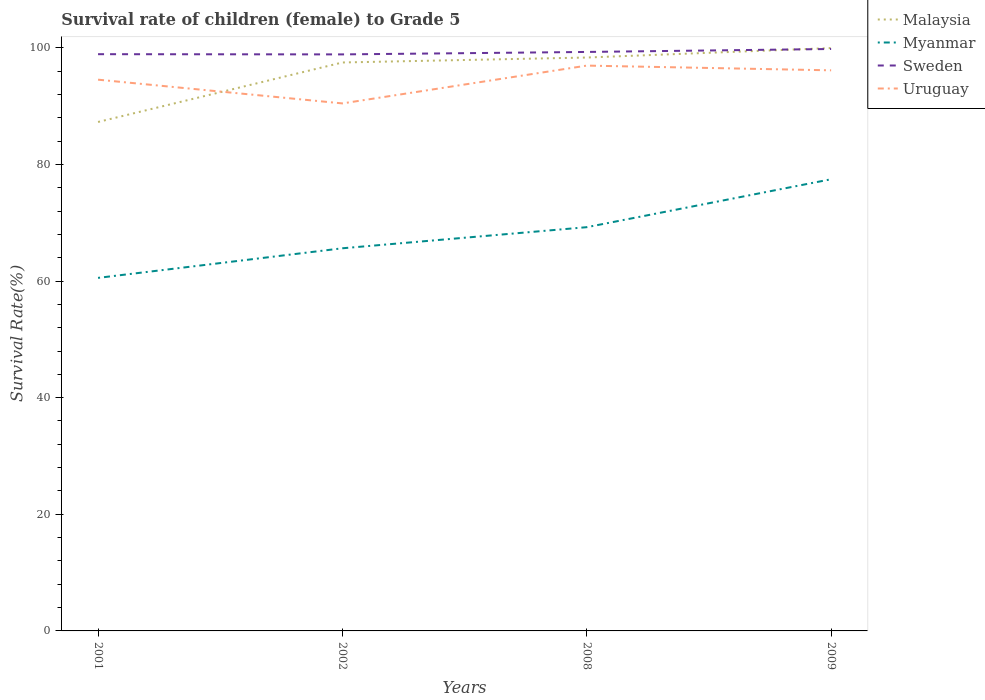Does the line corresponding to Uruguay intersect with the line corresponding to Sweden?
Give a very brief answer. No. Is the number of lines equal to the number of legend labels?
Keep it short and to the point. Yes. Across all years, what is the maximum survival rate of female children to grade 5 in Myanmar?
Your answer should be compact. 60.54. What is the total survival rate of female children to grade 5 in Myanmar in the graph?
Keep it short and to the point. -16.91. What is the difference between the highest and the second highest survival rate of female children to grade 5 in Uruguay?
Offer a terse response. 6.48. Is the survival rate of female children to grade 5 in Uruguay strictly greater than the survival rate of female children to grade 5 in Myanmar over the years?
Offer a terse response. No. How many years are there in the graph?
Your answer should be very brief. 4. What is the difference between two consecutive major ticks on the Y-axis?
Provide a succinct answer. 20. Does the graph contain any zero values?
Ensure brevity in your answer.  No. Where does the legend appear in the graph?
Ensure brevity in your answer.  Top right. What is the title of the graph?
Give a very brief answer. Survival rate of children (female) to Grade 5. Does "Greenland" appear as one of the legend labels in the graph?
Ensure brevity in your answer.  No. What is the label or title of the Y-axis?
Your answer should be very brief. Survival Rate(%). What is the Survival Rate(%) of Malaysia in 2001?
Ensure brevity in your answer.  87.27. What is the Survival Rate(%) in Myanmar in 2001?
Provide a succinct answer. 60.54. What is the Survival Rate(%) of Sweden in 2001?
Provide a succinct answer. 98.9. What is the Survival Rate(%) of Uruguay in 2001?
Provide a short and direct response. 94.53. What is the Survival Rate(%) of Malaysia in 2002?
Offer a terse response. 97.48. What is the Survival Rate(%) in Myanmar in 2002?
Ensure brevity in your answer.  65.61. What is the Survival Rate(%) in Sweden in 2002?
Provide a succinct answer. 98.86. What is the Survival Rate(%) in Uruguay in 2002?
Provide a short and direct response. 90.46. What is the Survival Rate(%) of Malaysia in 2008?
Your response must be concise. 98.32. What is the Survival Rate(%) of Myanmar in 2008?
Your answer should be very brief. 69.23. What is the Survival Rate(%) in Sweden in 2008?
Your answer should be very brief. 99.28. What is the Survival Rate(%) in Uruguay in 2008?
Keep it short and to the point. 96.94. What is the Survival Rate(%) of Malaysia in 2009?
Offer a terse response. 99.95. What is the Survival Rate(%) in Myanmar in 2009?
Ensure brevity in your answer.  77.45. What is the Survival Rate(%) of Sweden in 2009?
Keep it short and to the point. 99.79. What is the Survival Rate(%) in Uruguay in 2009?
Your answer should be very brief. 96.13. Across all years, what is the maximum Survival Rate(%) of Malaysia?
Ensure brevity in your answer.  99.95. Across all years, what is the maximum Survival Rate(%) in Myanmar?
Make the answer very short. 77.45. Across all years, what is the maximum Survival Rate(%) of Sweden?
Your answer should be very brief. 99.79. Across all years, what is the maximum Survival Rate(%) of Uruguay?
Offer a terse response. 96.94. Across all years, what is the minimum Survival Rate(%) of Malaysia?
Provide a short and direct response. 87.27. Across all years, what is the minimum Survival Rate(%) in Myanmar?
Your response must be concise. 60.54. Across all years, what is the minimum Survival Rate(%) of Sweden?
Give a very brief answer. 98.86. Across all years, what is the minimum Survival Rate(%) in Uruguay?
Your answer should be compact. 90.46. What is the total Survival Rate(%) in Malaysia in the graph?
Keep it short and to the point. 383.02. What is the total Survival Rate(%) in Myanmar in the graph?
Provide a short and direct response. 272.84. What is the total Survival Rate(%) of Sweden in the graph?
Ensure brevity in your answer.  396.83. What is the total Survival Rate(%) of Uruguay in the graph?
Ensure brevity in your answer.  378.05. What is the difference between the Survival Rate(%) of Malaysia in 2001 and that in 2002?
Your answer should be very brief. -10.2. What is the difference between the Survival Rate(%) in Myanmar in 2001 and that in 2002?
Give a very brief answer. -5.08. What is the difference between the Survival Rate(%) of Sweden in 2001 and that in 2002?
Your response must be concise. 0.04. What is the difference between the Survival Rate(%) in Uruguay in 2001 and that in 2002?
Your response must be concise. 4.07. What is the difference between the Survival Rate(%) in Malaysia in 2001 and that in 2008?
Offer a very short reply. -11.05. What is the difference between the Survival Rate(%) of Myanmar in 2001 and that in 2008?
Ensure brevity in your answer.  -8.69. What is the difference between the Survival Rate(%) in Sweden in 2001 and that in 2008?
Offer a terse response. -0.38. What is the difference between the Survival Rate(%) in Uruguay in 2001 and that in 2008?
Provide a short and direct response. -2.41. What is the difference between the Survival Rate(%) of Malaysia in 2001 and that in 2009?
Give a very brief answer. -12.67. What is the difference between the Survival Rate(%) in Myanmar in 2001 and that in 2009?
Ensure brevity in your answer.  -16.91. What is the difference between the Survival Rate(%) of Sweden in 2001 and that in 2009?
Your answer should be compact. -0.89. What is the difference between the Survival Rate(%) of Uruguay in 2001 and that in 2009?
Ensure brevity in your answer.  -1.6. What is the difference between the Survival Rate(%) of Malaysia in 2002 and that in 2008?
Ensure brevity in your answer.  -0.85. What is the difference between the Survival Rate(%) of Myanmar in 2002 and that in 2008?
Your answer should be compact. -3.62. What is the difference between the Survival Rate(%) of Sweden in 2002 and that in 2008?
Make the answer very short. -0.42. What is the difference between the Survival Rate(%) in Uruguay in 2002 and that in 2008?
Make the answer very short. -6.48. What is the difference between the Survival Rate(%) of Malaysia in 2002 and that in 2009?
Keep it short and to the point. -2.47. What is the difference between the Survival Rate(%) in Myanmar in 2002 and that in 2009?
Ensure brevity in your answer.  -11.84. What is the difference between the Survival Rate(%) of Sweden in 2002 and that in 2009?
Make the answer very short. -0.93. What is the difference between the Survival Rate(%) in Uruguay in 2002 and that in 2009?
Offer a very short reply. -5.67. What is the difference between the Survival Rate(%) of Malaysia in 2008 and that in 2009?
Offer a very short reply. -1.62. What is the difference between the Survival Rate(%) in Myanmar in 2008 and that in 2009?
Provide a short and direct response. -8.22. What is the difference between the Survival Rate(%) of Sweden in 2008 and that in 2009?
Provide a succinct answer. -0.51. What is the difference between the Survival Rate(%) of Uruguay in 2008 and that in 2009?
Provide a short and direct response. 0.81. What is the difference between the Survival Rate(%) in Malaysia in 2001 and the Survival Rate(%) in Myanmar in 2002?
Offer a terse response. 21.66. What is the difference between the Survival Rate(%) of Malaysia in 2001 and the Survival Rate(%) of Sweden in 2002?
Provide a short and direct response. -11.59. What is the difference between the Survival Rate(%) in Malaysia in 2001 and the Survival Rate(%) in Uruguay in 2002?
Your response must be concise. -3.18. What is the difference between the Survival Rate(%) of Myanmar in 2001 and the Survival Rate(%) of Sweden in 2002?
Your response must be concise. -38.32. What is the difference between the Survival Rate(%) in Myanmar in 2001 and the Survival Rate(%) in Uruguay in 2002?
Offer a very short reply. -29.92. What is the difference between the Survival Rate(%) of Sweden in 2001 and the Survival Rate(%) of Uruguay in 2002?
Keep it short and to the point. 8.44. What is the difference between the Survival Rate(%) of Malaysia in 2001 and the Survival Rate(%) of Myanmar in 2008?
Offer a very short reply. 18.04. What is the difference between the Survival Rate(%) of Malaysia in 2001 and the Survival Rate(%) of Sweden in 2008?
Keep it short and to the point. -12.01. What is the difference between the Survival Rate(%) in Malaysia in 2001 and the Survival Rate(%) in Uruguay in 2008?
Your response must be concise. -9.67. What is the difference between the Survival Rate(%) in Myanmar in 2001 and the Survival Rate(%) in Sweden in 2008?
Ensure brevity in your answer.  -38.74. What is the difference between the Survival Rate(%) in Myanmar in 2001 and the Survival Rate(%) in Uruguay in 2008?
Your response must be concise. -36.4. What is the difference between the Survival Rate(%) of Sweden in 2001 and the Survival Rate(%) of Uruguay in 2008?
Offer a terse response. 1.96. What is the difference between the Survival Rate(%) of Malaysia in 2001 and the Survival Rate(%) of Myanmar in 2009?
Make the answer very short. 9.82. What is the difference between the Survival Rate(%) in Malaysia in 2001 and the Survival Rate(%) in Sweden in 2009?
Keep it short and to the point. -12.52. What is the difference between the Survival Rate(%) in Malaysia in 2001 and the Survival Rate(%) in Uruguay in 2009?
Your response must be concise. -8.86. What is the difference between the Survival Rate(%) of Myanmar in 2001 and the Survival Rate(%) of Sweden in 2009?
Offer a very short reply. -39.25. What is the difference between the Survival Rate(%) in Myanmar in 2001 and the Survival Rate(%) in Uruguay in 2009?
Your answer should be compact. -35.59. What is the difference between the Survival Rate(%) of Sweden in 2001 and the Survival Rate(%) of Uruguay in 2009?
Keep it short and to the point. 2.77. What is the difference between the Survival Rate(%) in Malaysia in 2002 and the Survival Rate(%) in Myanmar in 2008?
Offer a terse response. 28.24. What is the difference between the Survival Rate(%) of Malaysia in 2002 and the Survival Rate(%) of Sweden in 2008?
Your answer should be compact. -1.8. What is the difference between the Survival Rate(%) of Malaysia in 2002 and the Survival Rate(%) of Uruguay in 2008?
Your answer should be compact. 0.54. What is the difference between the Survival Rate(%) in Myanmar in 2002 and the Survival Rate(%) in Sweden in 2008?
Your answer should be very brief. -33.67. What is the difference between the Survival Rate(%) in Myanmar in 2002 and the Survival Rate(%) in Uruguay in 2008?
Provide a succinct answer. -31.33. What is the difference between the Survival Rate(%) of Sweden in 2002 and the Survival Rate(%) of Uruguay in 2008?
Your response must be concise. 1.92. What is the difference between the Survival Rate(%) in Malaysia in 2002 and the Survival Rate(%) in Myanmar in 2009?
Ensure brevity in your answer.  20.02. What is the difference between the Survival Rate(%) of Malaysia in 2002 and the Survival Rate(%) of Sweden in 2009?
Make the answer very short. -2.31. What is the difference between the Survival Rate(%) of Malaysia in 2002 and the Survival Rate(%) of Uruguay in 2009?
Your answer should be very brief. 1.35. What is the difference between the Survival Rate(%) in Myanmar in 2002 and the Survival Rate(%) in Sweden in 2009?
Make the answer very short. -34.17. What is the difference between the Survival Rate(%) in Myanmar in 2002 and the Survival Rate(%) in Uruguay in 2009?
Your response must be concise. -30.51. What is the difference between the Survival Rate(%) in Sweden in 2002 and the Survival Rate(%) in Uruguay in 2009?
Ensure brevity in your answer.  2.73. What is the difference between the Survival Rate(%) in Malaysia in 2008 and the Survival Rate(%) in Myanmar in 2009?
Offer a very short reply. 20.87. What is the difference between the Survival Rate(%) of Malaysia in 2008 and the Survival Rate(%) of Sweden in 2009?
Give a very brief answer. -1.46. What is the difference between the Survival Rate(%) in Malaysia in 2008 and the Survival Rate(%) in Uruguay in 2009?
Provide a short and direct response. 2.2. What is the difference between the Survival Rate(%) in Myanmar in 2008 and the Survival Rate(%) in Sweden in 2009?
Provide a succinct answer. -30.56. What is the difference between the Survival Rate(%) in Myanmar in 2008 and the Survival Rate(%) in Uruguay in 2009?
Your response must be concise. -26.9. What is the difference between the Survival Rate(%) in Sweden in 2008 and the Survival Rate(%) in Uruguay in 2009?
Offer a terse response. 3.15. What is the average Survival Rate(%) in Malaysia per year?
Keep it short and to the point. 95.75. What is the average Survival Rate(%) in Myanmar per year?
Make the answer very short. 68.21. What is the average Survival Rate(%) in Sweden per year?
Provide a short and direct response. 99.21. What is the average Survival Rate(%) in Uruguay per year?
Offer a terse response. 94.51. In the year 2001, what is the difference between the Survival Rate(%) in Malaysia and Survival Rate(%) in Myanmar?
Your response must be concise. 26.73. In the year 2001, what is the difference between the Survival Rate(%) of Malaysia and Survival Rate(%) of Sweden?
Provide a short and direct response. -11.63. In the year 2001, what is the difference between the Survival Rate(%) of Malaysia and Survival Rate(%) of Uruguay?
Offer a very short reply. -7.25. In the year 2001, what is the difference between the Survival Rate(%) in Myanmar and Survival Rate(%) in Sweden?
Ensure brevity in your answer.  -38.36. In the year 2001, what is the difference between the Survival Rate(%) in Myanmar and Survival Rate(%) in Uruguay?
Offer a terse response. -33.99. In the year 2001, what is the difference between the Survival Rate(%) in Sweden and Survival Rate(%) in Uruguay?
Your answer should be very brief. 4.37. In the year 2002, what is the difference between the Survival Rate(%) of Malaysia and Survival Rate(%) of Myanmar?
Your answer should be very brief. 31.86. In the year 2002, what is the difference between the Survival Rate(%) of Malaysia and Survival Rate(%) of Sweden?
Your answer should be compact. -1.39. In the year 2002, what is the difference between the Survival Rate(%) in Malaysia and Survival Rate(%) in Uruguay?
Your answer should be compact. 7.02. In the year 2002, what is the difference between the Survival Rate(%) in Myanmar and Survival Rate(%) in Sweden?
Provide a short and direct response. -33.25. In the year 2002, what is the difference between the Survival Rate(%) of Myanmar and Survival Rate(%) of Uruguay?
Provide a succinct answer. -24.84. In the year 2002, what is the difference between the Survival Rate(%) in Sweden and Survival Rate(%) in Uruguay?
Provide a succinct answer. 8.41. In the year 2008, what is the difference between the Survival Rate(%) in Malaysia and Survival Rate(%) in Myanmar?
Make the answer very short. 29.09. In the year 2008, what is the difference between the Survival Rate(%) of Malaysia and Survival Rate(%) of Sweden?
Offer a very short reply. -0.96. In the year 2008, what is the difference between the Survival Rate(%) of Malaysia and Survival Rate(%) of Uruguay?
Offer a terse response. 1.38. In the year 2008, what is the difference between the Survival Rate(%) in Myanmar and Survival Rate(%) in Sweden?
Offer a terse response. -30.05. In the year 2008, what is the difference between the Survival Rate(%) of Myanmar and Survival Rate(%) of Uruguay?
Make the answer very short. -27.71. In the year 2008, what is the difference between the Survival Rate(%) in Sweden and Survival Rate(%) in Uruguay?
Provide a succinct answer. 2.34. In the year 2009, what is the difference between the Survival Rate(%) in Malaysia and Survival Rate(%) in Myanmar?
Give a very brief answer. 22.5. In the year 2009, what is the difference between the Survival Rate(%) of Malaysia and Survival Rate(%) of Sweden?
Offer a very short reply. 0.16. In the year 2009, what is the difference between the Survival Rate(%) in Malaysia and Survival Rate(%) in Uruguay?
Provide a short and direct response. 3.82. In the year 2009, what is the difference between the Survival Rate(%) in Myanmar and Survival Rate(%) in Sweden?
Provide a short and direct response. -22.34. In the year 2009, what is the difference between the Survival Rate(%) in Myanmar and Survival Rate(%) in Uruguay?
Offer a very short reply. -18.68. In the year 2009, what is the difference between the Survival Rate(%) of Sweden and Survival Rate(%) of Uruguay?
Provide a succinct answer. 3.66. What is the ratio of the Survival Rate(%) in Malaysia in 2001 to that in 2002?
Keep it short and to the point. 0.9. What is the ratio of the Survival Rate(%) of Myanmar in 2001 to that in 2002?
Provide a succinct answer. 0.92. What is the ratio of the Survival Rate(%) in Sweden in 2001 to that in 2002?
Your answer should be compact. 1. What is the ratio of the Survival Rate(%) in Uruguay in 2001 to that in 2002?
Keep it short and to the point. 1.04. What is the ratio of the Survival Rate(%) in Malaysia in 2001 to that in 2008?
Your response must be concise. 0.89. What is the ratio of the Survival Rate(%) of Myanmar in 2001 to that in 2008?
Provide a succinct answer. 0.87. What is the ratio of the Survival Rate(%) of Uruguay in 2001 to that in 2008?
Provide a succinct answer. 0.98. What is the ratio of the Survival Rate(%) of Malaysia in 2001 to that in 2009?
Offer a terse response. 0.87. What is the ratio of the Survival Rate(%) in Myanmar in 2001 to that in 2009?
Keep it short and to the point. 0.78. What is the ratio of the Survival Rate(%) of Uruguay in 2001 to that in 2009?
Give a very brief answer. 0.98. What is the ratio of the Survival Rate(%) of Malaysia in 2002 to that in 2008?
Provide a succinct answer. 0.99. What is the ratio of the Survival Rate(%) of Myanmar in 2002 to that in 2008?
Give a very brief answer. 0.95. What is the ratio of the Survival Rate(%) in Sweden in 2002 to that in 2008?
Ensure brevity in your answer.  1. What is the ratio of the Survival Rate(%) in Uruguay in 2002 to that in 2008?
Your response must be concise. 0.93. What is the ratio of the Survival Rate(%) of Malaysia in 2002 to that in 2009?
Give a very brief answer. 0.98. What is the ratio of the Survival Rate(%) of Myanmar in 2002 to that in 2009?
Provide a succinct answer. 0.85. What is the ratio of the Survival Rate(%) in Sweden in 2002 to that in 2009?
Your answer should be compact. 0.99. What is the ratio of the Survival Rate(%) in Uruguay in 2002 to that in 2009?
Give a very brief answer. 0.94. What is the ratio of the Survival Rate(%) in Malaysia in 2008 to that in 2009?
Your answer should be compact. 0.98. What is the ratio of the Survival Rate(%) of Myanmar in 2008 to that in 2009?
Give a very brief answer. 0.89. What is the ratio of the Survival Rate(%) of Sweden in 2008 to that in 2009?
Keep it short and to the point. 0.99. What is the ratio of the Survival Rate(%) in Uruguay in 2008 to that in 2009?
Ensure brevity in your answer.  1.01. What is the difference between the highest and the second highest Survival Rate(%) in Malaysia?
Ensure brevity in your answer.  1.62. What is the difference between the highest and the second highest Survival Rate(%) of Myanmar?
Keep it short and to the point. 8.22. What is the difference between the highest and the second highest Survival Rate(%) in Sweden?
Offer a very short reply. 0.51. What is the difference between the highest and the second highest Survival Rate(%) in Uruguay?
Your response must be concise. 0.81. What is the difference between the highest and the lowest Survival Rate(%) of Malaysia?
Offer a very short reply. 12.67. What is the difference between the highest and the lowest Survival Rate(%) in Myanmar?
Keep it short and to the point. 16.91. What is the difference between the highest and the lowest Survival Rate(%) in Sweden?
Give a very brief answer. 0.93. What is the difference between the highest and the lowest Survival Rate(%) of Uruguay?
Your response must be concise. 6.48. 